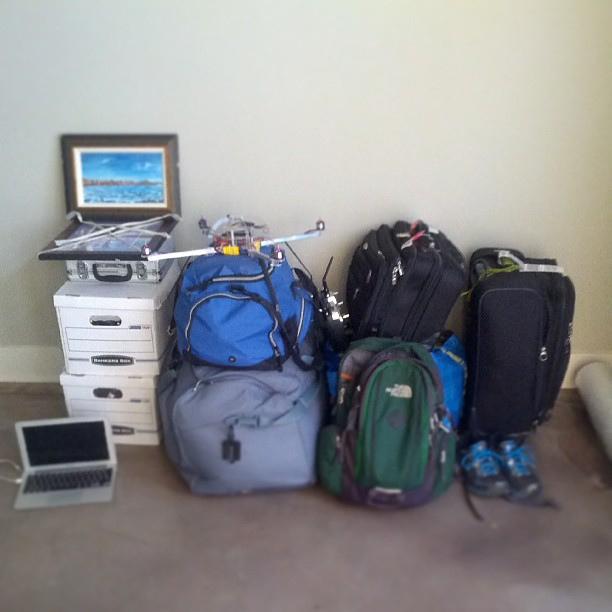How many bags are blue?
Answer briefly. 2. How many laptops are there?
Keep it brief. 2. How many pieces of unattended luggage are there?
Give a very brief answer. 5. Is the laptop open?
Be succinct. Yes. 